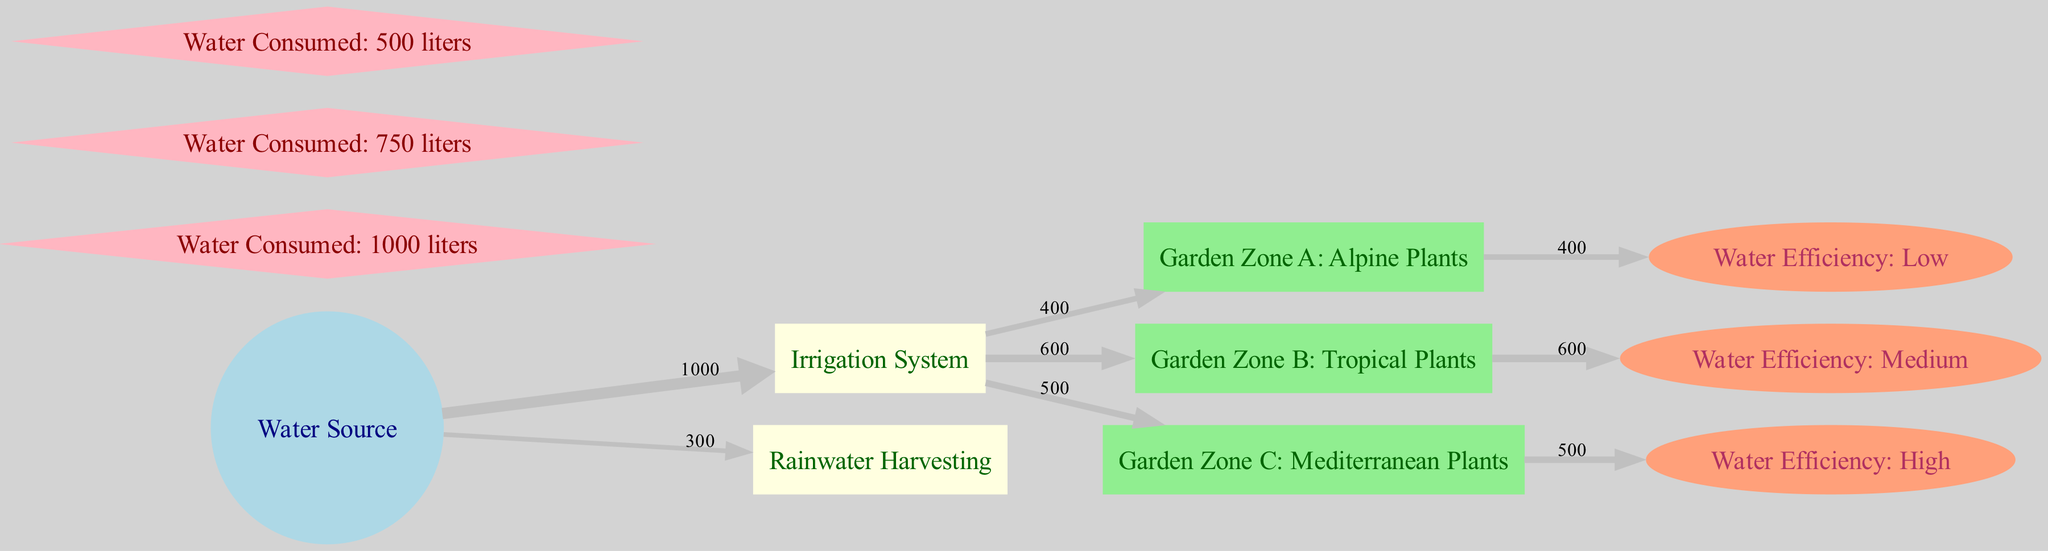What is the total amount of water consumed in Garden Zone B? By examining the links in the diagram, I can see that Garden Zone B: Tropical Plants consumes 750 liters of water as indicated by the corresponding link from the irrigation system.
Answer: 750 liters Which garden zone has the highest water efficiency? Looking at the water efficiency nodes, I find that the highest category is Water Efficiency: High, which corresponds to Garden Zone C: Mediterranean Plants as shown by the link.
Answer: Garden Zone C: Mediterranean Plants How many total nodes are present in the diagram? Counting the nodes listed in the data provides the total number of distinct nodes. There are 10 nodes in total, including water sources, garden zones, and water efficiencies.
Answer: 10 What source contributes the least amount of water to the irrigation system? I can see from the links that while the water source feeds into both the irrigation system and rainwater harvesting, the least amount of water (300 liters) is attributed to Rainwater Harvesting from the water source.
Answer: Rainwater Harvesting What is the water consumption for Garden Zone A? By checking the corresponding link from the irrigation system to Garden Zone A: Alpine Plants, I find that it consumes 400 liters of water.
Answer: 400 liters Which irrigation system feeds the highest amount of water to Garden Zone C? Referring to the flow from the irrigation system to Garden Zone C: Mediterranean Plants, I can see that it receives 500 liters of water, confirming it as the highest among the zones listed.
Answer: 500 liters What portion of the total water source is allocated to the irrigation system? The irrigation system receives 1000 liters from the water source, which is the main channel of water flow. Therefore this is the full allocation to this specific system.
Answer: 1000 liters What is the efficiency level of Garden Zone A? By observing the link from Garden Zone A: Alpine Plants to its corresponding efficiency node, I can see that the efficiency level is classified as Low.
Answer: Low 